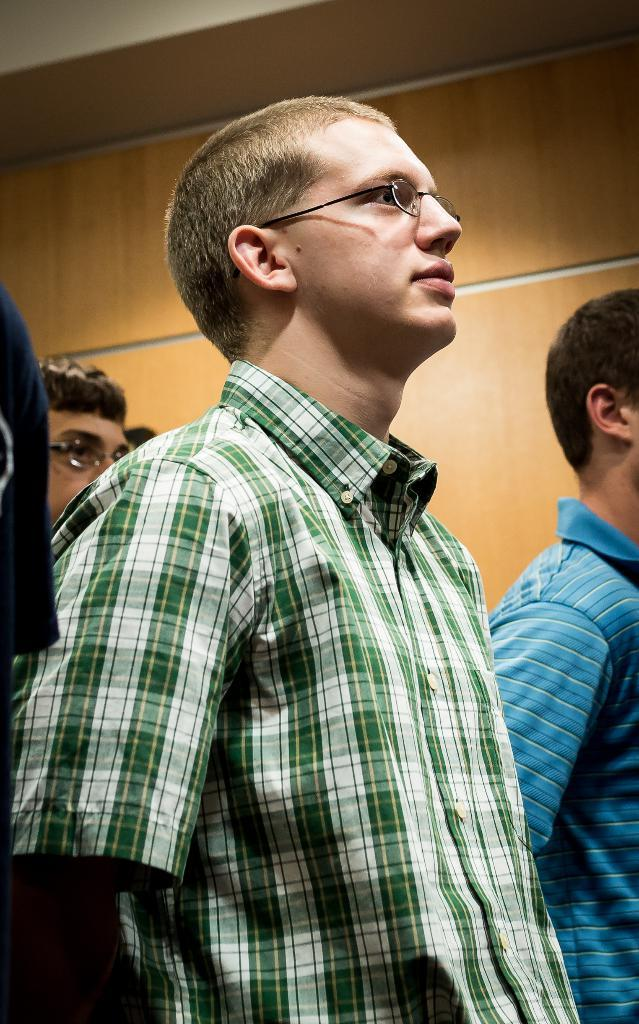How many people are in the image? There is a group of persons standing in the image. What can be seen in the background of the image? There is a wall in the background of the image. What type of sign is being held by the men in the image? There are no men or signs present in the image; it only shows a group of persons standing in front of a wall. 